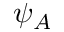<formula> <loc_0><loc_0><loc_500><loc_500>\psi _ { A }</formula> 